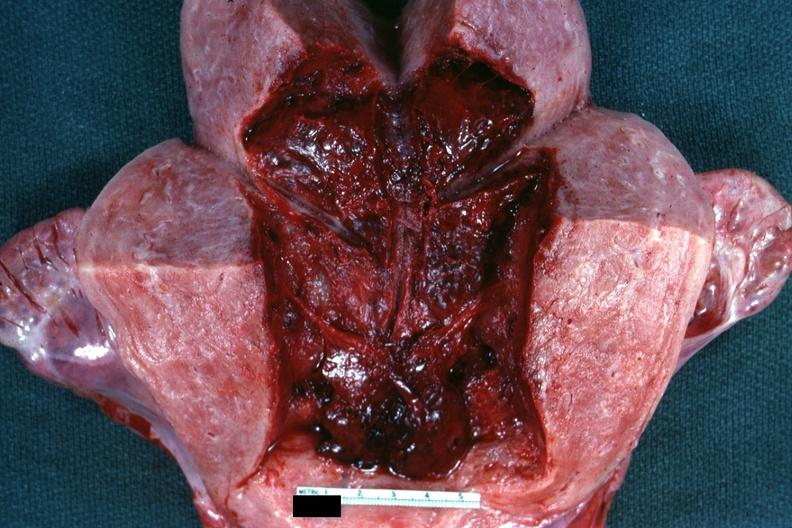s postpartum present?
Answer the question using a single word or phrase. Yes 